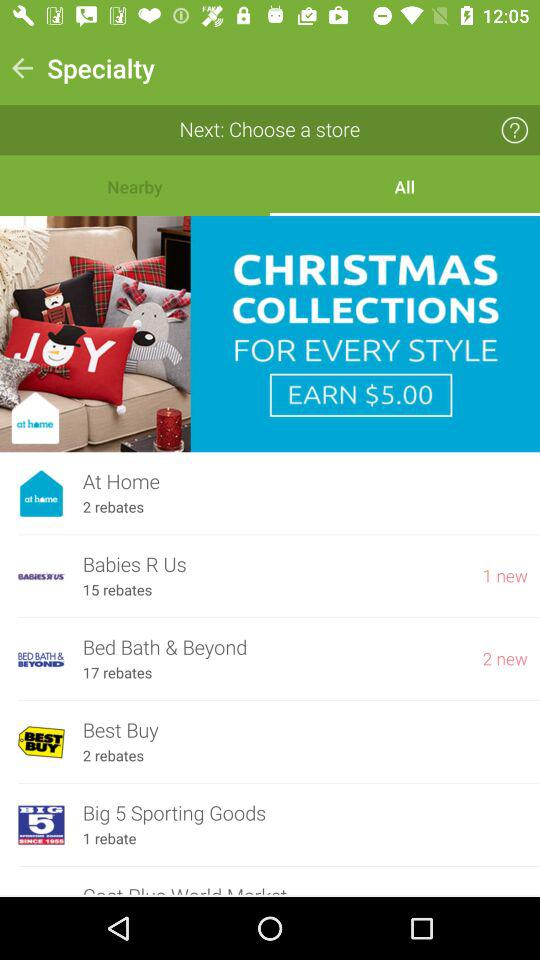Which tab is selected? The selected tab is "All". 